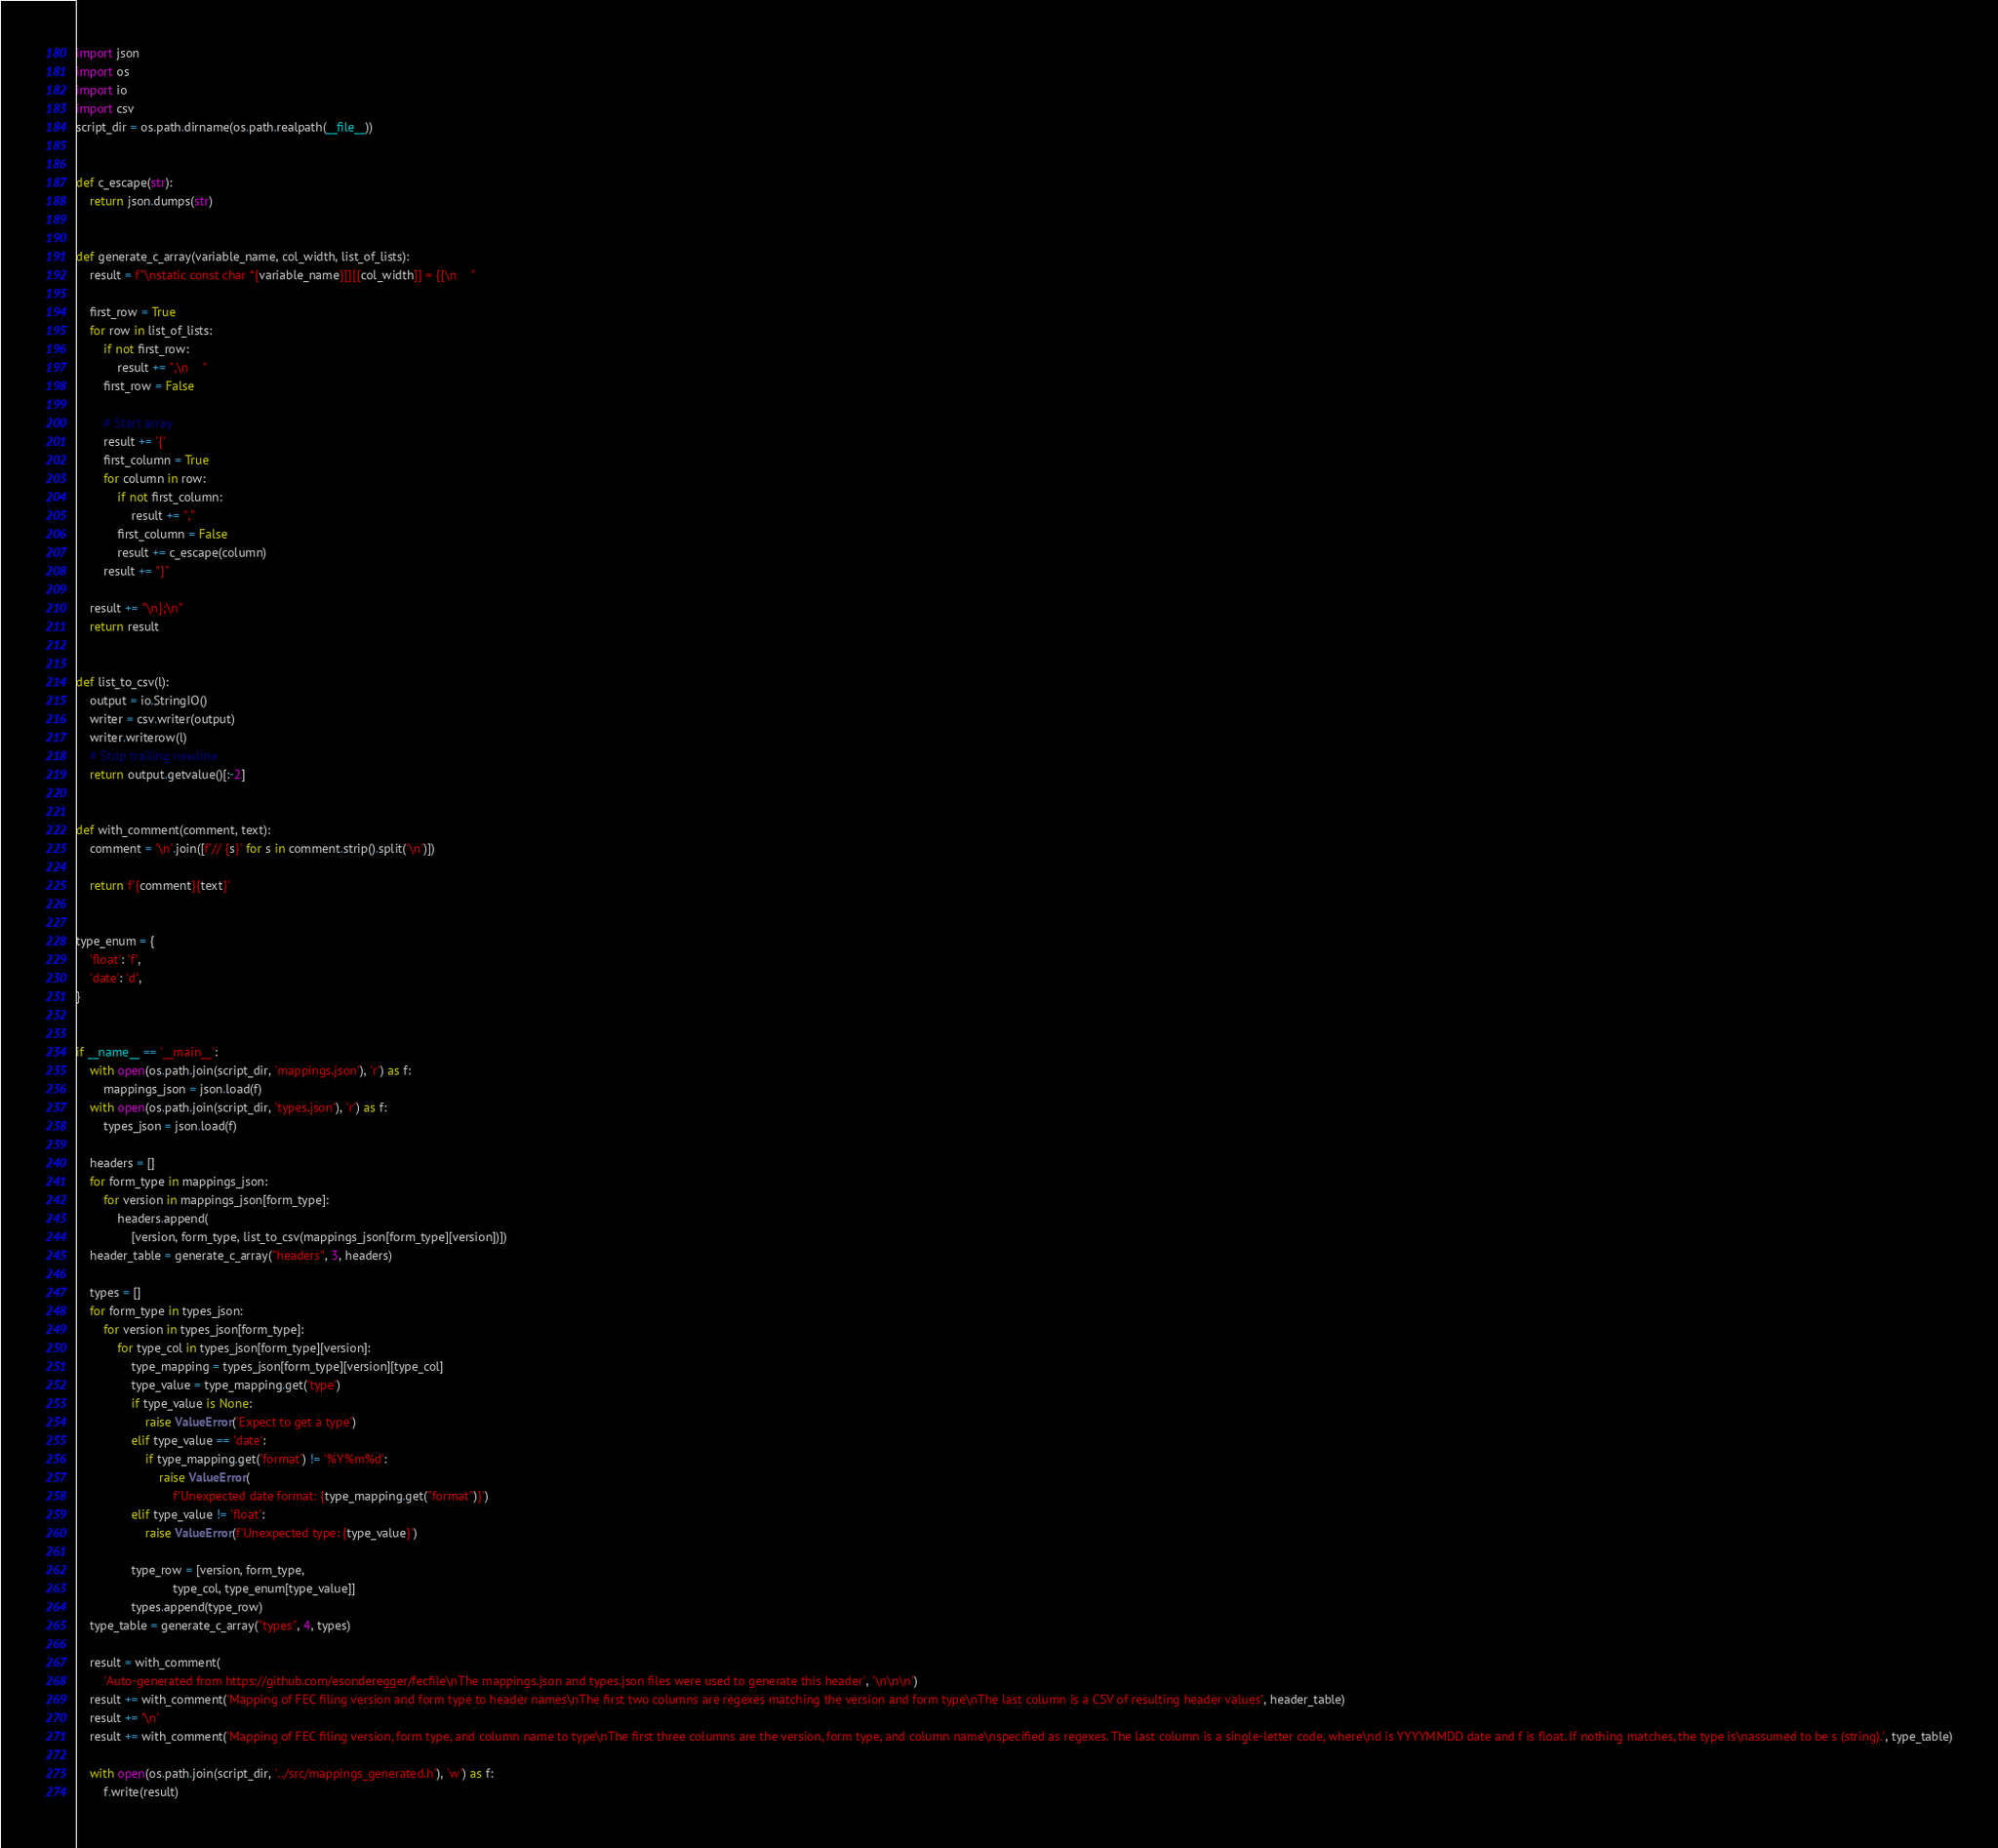<code> <loc_0><loc_0><loc_500><loc_500><_Python_>import json
import os
import io
import csv
script_dir = os.path.dirname(os.path.realpath(__file__))


def c_escape(str):
    return json.dumps(str)


def generate_c_array(variable_name, col_width, list_of_lists):
    result = f"\nstatic const char *{variable_name}[][{col_width}] = {{\n    "

    first_row = True
    for row in list_of_lists:
        if not first_row:
            result += ",\n    "
        first_row = False

        # Start array
        result += '{'
        first_column = True
        for column in row:
            if not first_column:
                result += ","
            first_column = False
            result += c_escape(column)
        result += "}"

    result += "\n};\n"
    return result


def list_to_csv(l):
    output = io.StringIO()
    writer = csv.writer(output)
    writer.writerow(l)
    # Strip trailing newline
    return output.getvalue()[:-2]


def with_comment(comment, text):
    comment = '\n'.join([f'// {s}' for s in comment.strip().split('\n')])

    return f'{comment}{text}'


type_enum = {
    'float': 'f',
    'date': 'd',
}


if __name__ == '__main__':
    with open(os.path.join(script_dir, 'mappings.json'), 'r') as f:
        mappings_json = json.load(f)
    with open(os.path.join(script_dir, 'types.json'), 'r') as f:
        types_json = json.load(f)

    headers = []
    for form_type in mappings_json:
        for version in mappings_json[form_type]:
            headers.append(
                [version, form_type, list_to_csv(mappings_json[form_type][version])])
    header_table = generate_c_array("headers", 3, headers)

    types = []
    for form_type in types_json:
        for version in types_json[form_type]:
            for type_col in types_json[form_type][version]:
                type_mapping = types_json[form_type][version][type_col]
                type_value = type_mapping.get('type')
                if type_value is None:
                    raise ValueError('Expect to get a type')
                elif type_value == 'date':
                    if type_mapping.get('format') != '%Y%m%d':
                        raise ValueError(
                            f'Unexpected date format: {type_mapping.get("format")}')
                elif type_value != 'float':
                    raise ValueError(f'Unexpected type: {type_value}')

                type_row = [version, form_type,
                            type_col, type_enum[type_value]]
                types.append(type_row)
    type_table = generate_c_array("types", 4, types)

    result = with_comment(
        'Auto-generated from https://github.com/esonderegger/fecfile\nThe mappings.json and types.json files were used to generate this header', '\n\n\n')
    result += with_comment('Mapping of FEC filing version and form type to header names\nThe first two columns are regexes matching the version and form type\nThe last column is a CSV of resulting header values', header_table)
    result += '\n'
    result += with_comment('Mapping of FEC filing version, form type, and column name to type\nThe first three columns are the version, form type, and column name\nspecified as regexes. The last column is a single-letter code, where\nd is YYYYMMDD date and f is float. If nothing matches, the type is\nassumed to be s (string).', type_table)

    with open(os.path.join(script_dir, '../src/mappings_generated.h'), 'w') as f:
        f.write(result)
</code> 